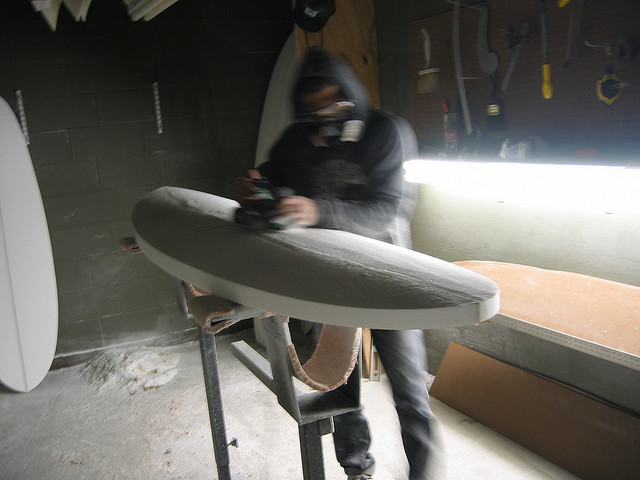Can you tell me about the equipment he is using? He's using what appears to be a power planer, a tool essential for the rough shaping phase of surfboard production. It helps in quickly removing excess foam to get the board closer to its final form before finer tools are used for the finishing touches. 